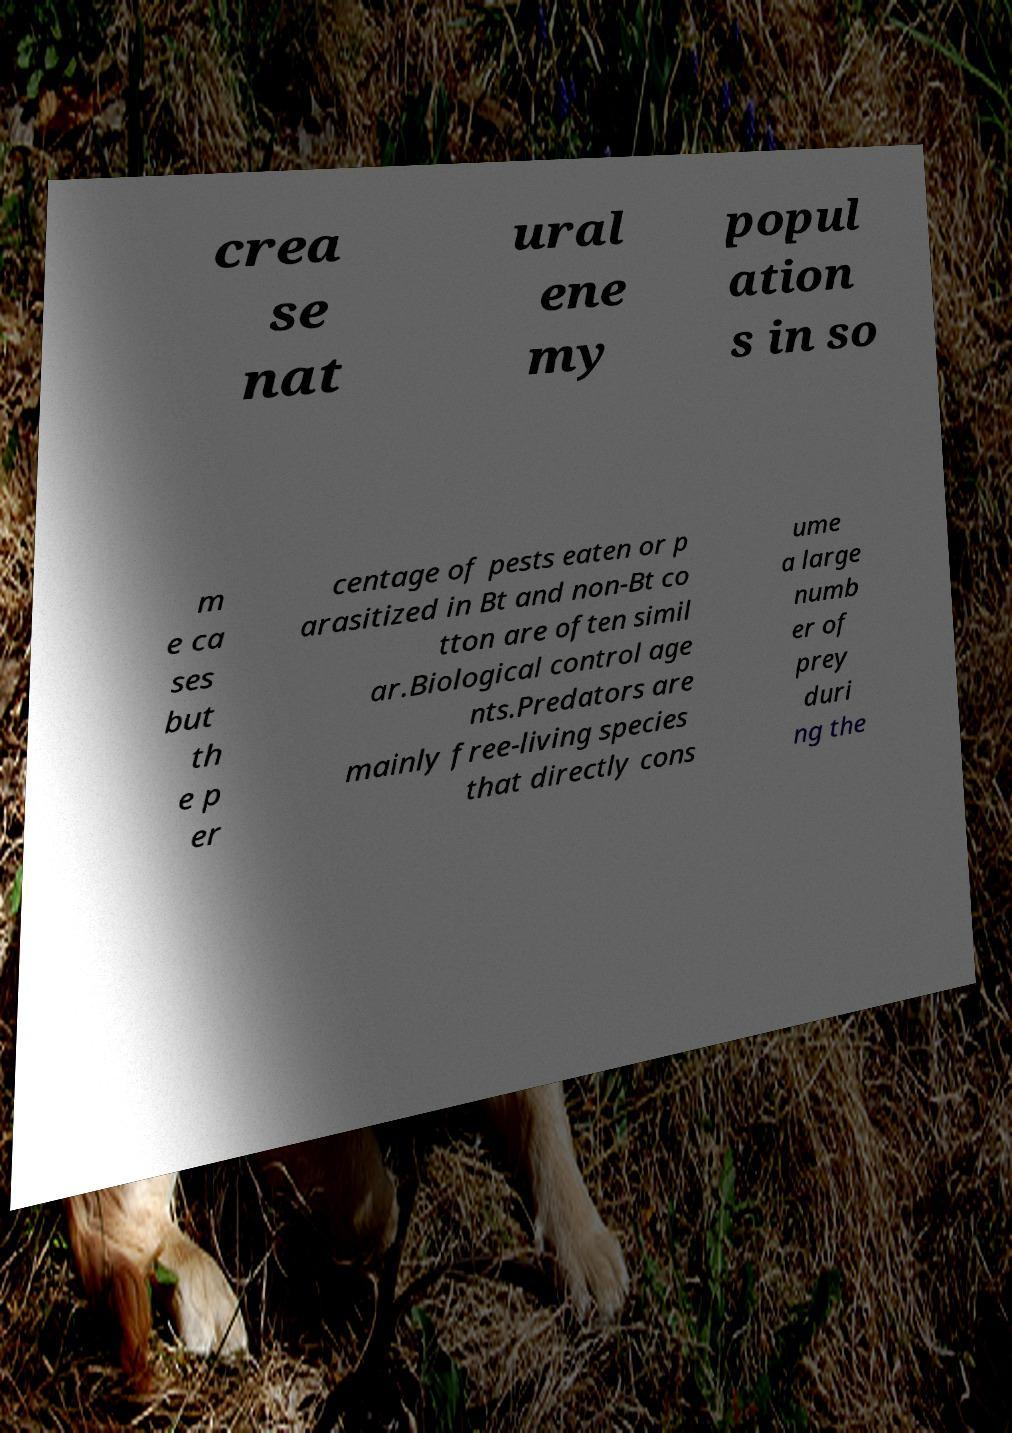Could you assist in decoding the text presented in this image and type it out clearly? crea se nat ural ene my popul ation s in so m e ca ses but th e p er centage of pests eaten or p arasitized in Bt and non-Bt co tton are often simil ar.Biological control age nts.Predators are mainly free-living species that directly cons ume a large numb er of prey duri ng the 